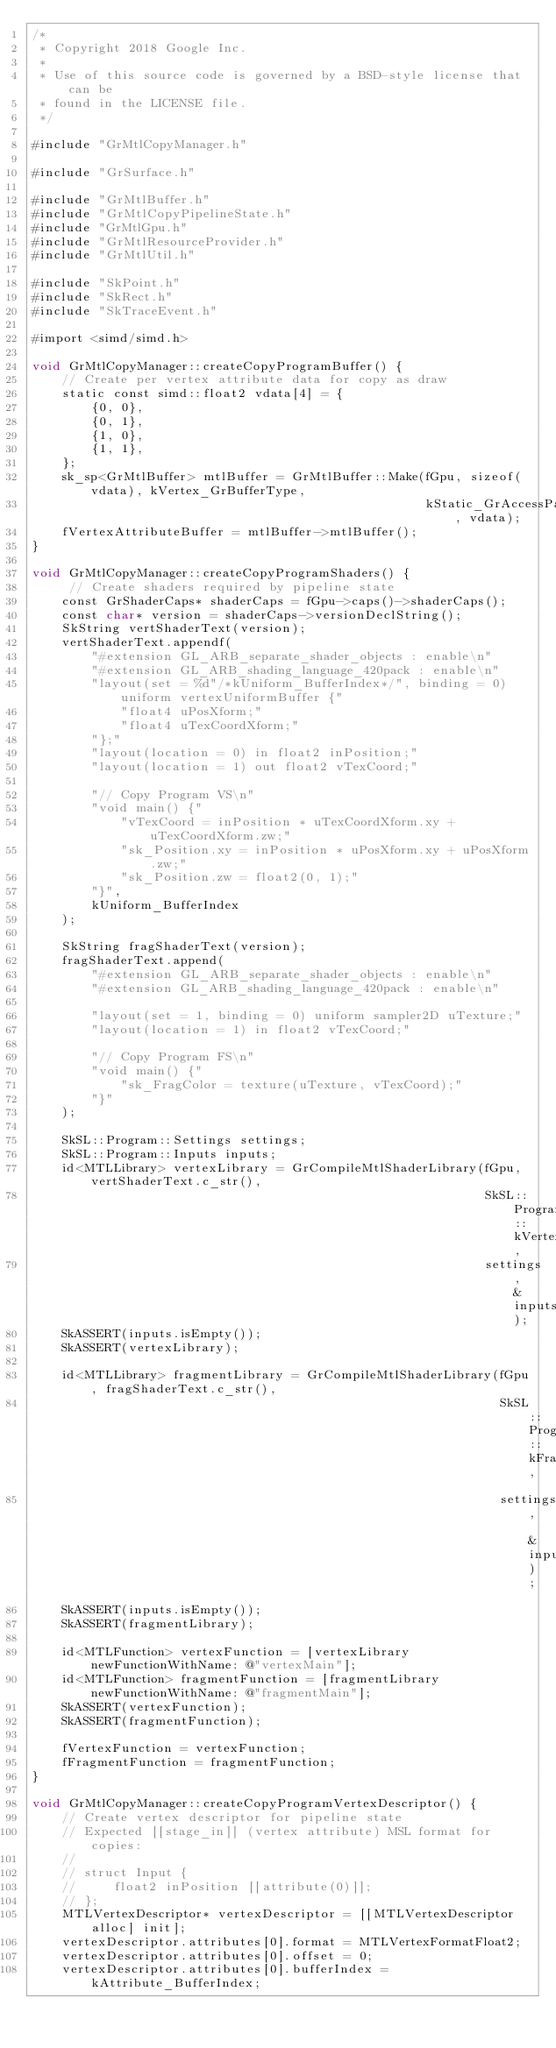<code> <loc_0><loc_0><loc_500><loc_500><_ObjectiveC_>/*
 * Copyright 2018 Google Inc.
 *
 * Use of this source code is governed by a BSD-style license that can be
 * found in the LICENSE file.
 */

#include "GrMtlCopyManager.h"

#include "GrSurface.h"

#include "GrMtlBuffer.h"
#include "GrMtlCopyPipelineState.h"
#include "GrMtlGpu.h"
#include "GrMtlResourceProvider.h"
#include "GrMtlUtil.h"

#include "SkPoint.h"
#include "SkRect.h"
#include "SkTraceEvent.h"

#import <simd/simd.h>

void GrMtlCopyManager::createCopyProgramBuffer() {
    // Create per vertex attribute data for copy as draw
    static const simd::float2 vdata[4] = {
        {0, 0},
        {0, 1},
        {1, 0},
        {1, 1},
    };
    sk_sp<GrMtlBuffer> mtlBuffer = GrMtlBuffer::Make(fGpu, sizeof(vdata), kVertex_GrBufferType,
                                                     kStatic_GrAccessPattern, vdata);
    fVertexAttributeBuffer = mtlBuffer->mtlBuffer();
}

void GrMtlCopyManager::createCopyProgramShaders() {
     // Create shaders required by pipeline state
    const GrShaderCaps* shaderCaps = fGpu->caps()->shaderCaps();
    const char* version = shaderCaps->versionDeclString();
    SkString vertShaderText(version);
    vertShaderText.appendf(
        "#extension GL_ARB_separate_shader_objects : enable\n"
        "#extension GL_ARB_shading_language_420pack : enable\n"
        "layout(set = %d"/*kUniform_BufferIndex*/", binding = 0) uniform vertexUniformBuffer {"
            "float4 uPosXform;"
            "float4 uTexCoordXform;"
        "};"
        "layout(location = 0) in float2 inPosition;"
        "layout(location = 1) out float2 vTexCoord;"

        "// Copy Program VS\n"
        "void main() {"
            "vTexCoord = inPosition * uTexCoordXform.xy + uTexCoordXform.zw;"
            "sk_Position.xy = inPosition * uPosXform.xy + uPosXform.zw;"
            "sk_Position.zw = float2(0, 1);"
        "}",
        kUniform_BufferIndex
    );

    SkString fragShaderText(version);
    fragShaderText.append(
        "#extension GL_ARB_separate_shader_objects : enable\n"
        "#extension GL_ARB_shading_language_420pack : enable\n"

        "layout(set = 1, binding = 0) uniform sampler2D uTexture;"
        "layout(location = 1) in float2 vTexCoord;"

        "// Copy Program FS\n"
        "void main() {"
            "sk_FragColor = texture(uTexture, vTexCoord);"
        "}"
    );

    SkSL::Program::Settings settings;
    SkSL::Program::Inputs inputs;
    id<MTLLibrary> vertexLibrary = GrCompileMtlShaderLibrary(fGpu, vertShaderText.c_str(),
                                                             SkSL::Program::kVertex_Kind,
                                                             settings, &inputs);
    SkASSERT(inputs.isEmpty());
    SkASSERT(vertexLibrary);

    id<MTLLibrary> fragmentLibrary = GrCompileMtlShaderLibrary(fGpu, fragShaderText.c_str(),
                                                               SkSL::Program::kFragment_Kind,
                                                               settings, &inputs);
    SkASSERT(inputs.isEmpty());
    SkASSERT(fragmentLibrary);

    id<MTLFunction> vertexFunction = [vertexLibrary newFunctionWithName: @"vertexMain"];
    id<MTLFunction> fragmentFunction = [fragmentLibrary newFunctionWithName: @"fragmentMain"];
    SkASSERT(vertexFunction);
    SkASSERT(fragmentFunction);

    fVertexFunction = vertexFunction;
    fFragmentFunction = fragmentFunction;
}

void GrMtlCopyManager::createCopyProgramVertexDescriptor() {
    // Create vertex descriptor for pipeline state
    // Expected [[stage_in]] (vertex attribute) MSL format for copies:
    //
    // struct Input {
    //     float2 inPosition [[attribute(0)]];
    // };
    MTLVertexDescriptor* vertexDescriptor = [[MTLVertexDescriptor alloc] init];
    vertexDescriptor.attributes[0].format = MTLVertexFormatFloat2;
    vertexDescriptor.attributes[0].offset = 0;
    vertexDescriptor.attributes[0].bufferIndex = kAttribute_BufferIndex;
</code> 